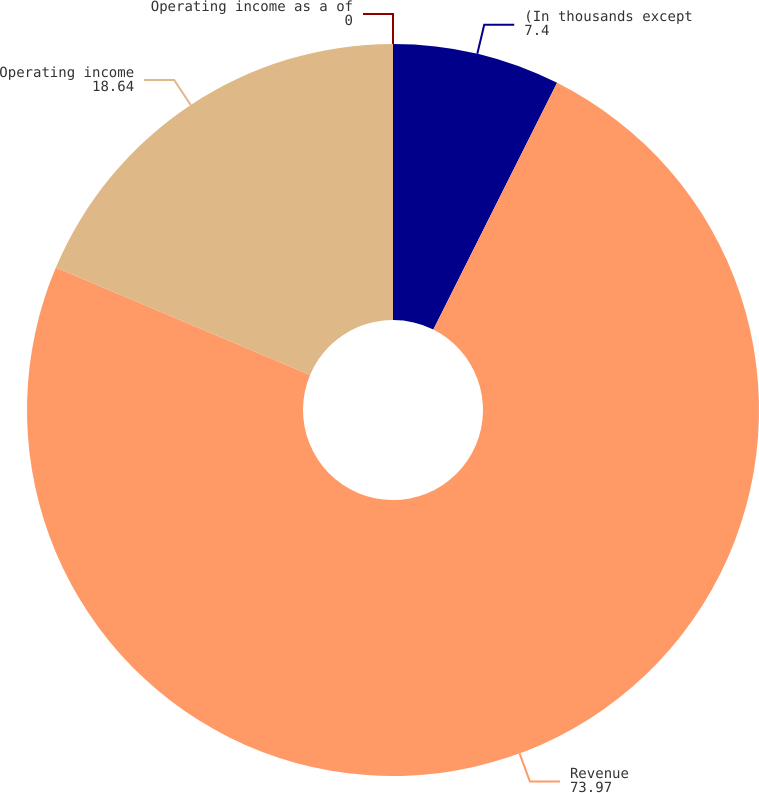Convert chart. <chart><loc_0><loc_0><loc_500><loc_500><pie_chart><fcel>(In thousands except<fcel>Revenue<fcel>Operating income<fcel>Operating income as a of<nl><fcel>7.4%<fcel>73.97%<fcel>18.64%<fcel>0.0%<nl></chart> 